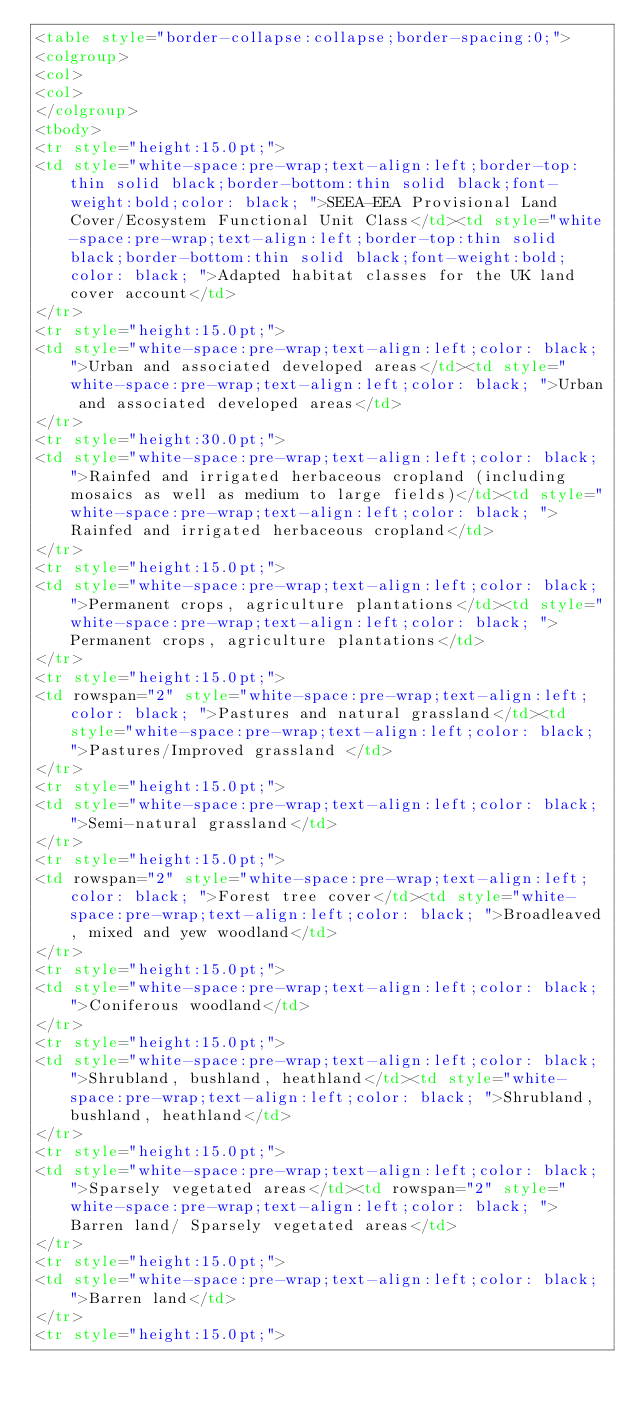Convert code to text. <code><loc_0><loc_0><loc_500><loc_500><_HTML_><table style="border-collapse:collapse;border-spacing:0;">
<colgroup>
<col>
<col>
</colgroup>
<tbody>
<tr style="height:15.0pt;">
<td style="white-space:pre-wrap;text-align:left;border-top:thin solid black;border-bottom:thin solid black;font-weight:bold;color: black; ">SEEA-EEA Provisional Land Cover/Ecosystem Functional Unit Class</td><td style="white-space:pre-wrap;text-align:left;border-top:thin solid black;border-bottom:thin solid black;font-weight:bold;color: black; ">Adapted habitat classes for the UK land cover account</td>
</tr>
<tr style="height:15.0pt;">
<td style="white-space:pre-wrap;text-align:left;color: black; ">Urban and associated developed areas</td><td style="white-space:pre-wrap;text-align:left;color: black; ">Urban and associated developed areas</td>
</tr>
<tr style="height:30.0pt;">
<td style="white-space:pre-wrap;text-align:left;color: black; ">Rainfed and irrigated herbaceous cropland (including mosaics as well as medium to large fields)</td><td style="white-space:pre-wrap;text-align:left;color: black; ">Rainfed and irrigated herbaceous cropland</td>
</tr>
<tr style="height:15.0pt;">
<td style="white-space:pre-wrap;text-align:left;color: black; ">Permanent crops, agriculture plantations</td><td style="white-space:pre-wrap;text-align:left;color: black; ">Permanent crops, agriculture plantations</td>
</tr>
<tr style="height:15.0pt;">
<td rowspan="2" style="white-space:pre-wrap;text-align:left;color: black; ">Pastures and natural grassland</td><td style="white-space:pre-wrap;text-align:left;color: black; ">Pastures/Improved grassland </td>
</tr>
<tr style="height:15.0pt;">
<td style="white-space:pre-wrap;text-align:left;color: black; ">Semi-natural grassland</td>
</tr>
<tr style="height:15.0pt;">
<td rowspan="2" style="white-space:pre-wrap;text-align:left;color: black; ">Forest tree cover</td><td style="white-space:pre-wrap;text-align:left;color: black; ">Broadleaved, mixed and yew woodland</td>
</tr>
<tr style="height:15.0pt;">
<td style="white-space:pre-wrap;text-align:left;color: black; ">Coniferous woodland</td>
</tr>
<tr style="height:15.0pt;">
<td style="white-space:pre-wrap;text-align:left;color: black; ">Shrubland, bushland, heathland</td><td style="white-space:pre-wrap;text-align:left;color: black; ">Shrubland, bushland, heathland</td>
</tr>
<tr style="height:15.0pt;">
<td style="white-space:pre-wrap;text-align:left;color: black; ">Sparsely vegetated areas</td><td rowspan="2" style="white-space:pre-wrap;text-align:left;color: black; ">Barren land/ Sparsely vegetated areas</td>
</tr>
<tr style="height:15.0pt;">
<td style="white-space:pre-wrap;text-align:left;color: black; ">Barren land</td>
</tr>
<tr style="height:15.0pt;"></code> 